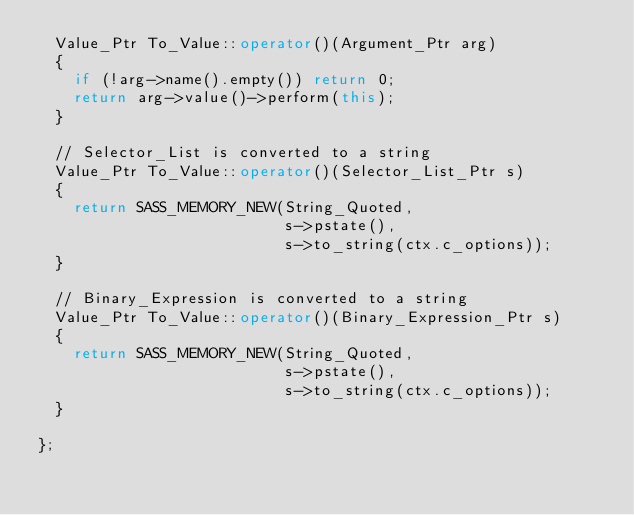<code> <loc_0><loc_0><loc_500><loc_500><_C++_>  Value_Ptr To_Value::operator()(Argument_Ptr arg)
  {
    if (!arg->name().empty()) return 0;
    return arg->value()->perform(this);
  }

  // Selector_List is converted to a string
  Value_Ptr To_Value::operator()(Selector_List_Ptr s)
  {
    return SASS_MEMORY_NEW(String_Quoted,
                           s->pstate(),
                           s->to_string(ctx.c_options));
  }

  // Binary_Expression is converted to a string
  Value_Ptr To_Value::operator()(Binary_Expression_Ptr s)
  {
    return SASS_MEMORY_NEW(String_Quoted,
                           s->pstate(),
                           s->to_string(ctx.c_options));
  }

};
</code> 